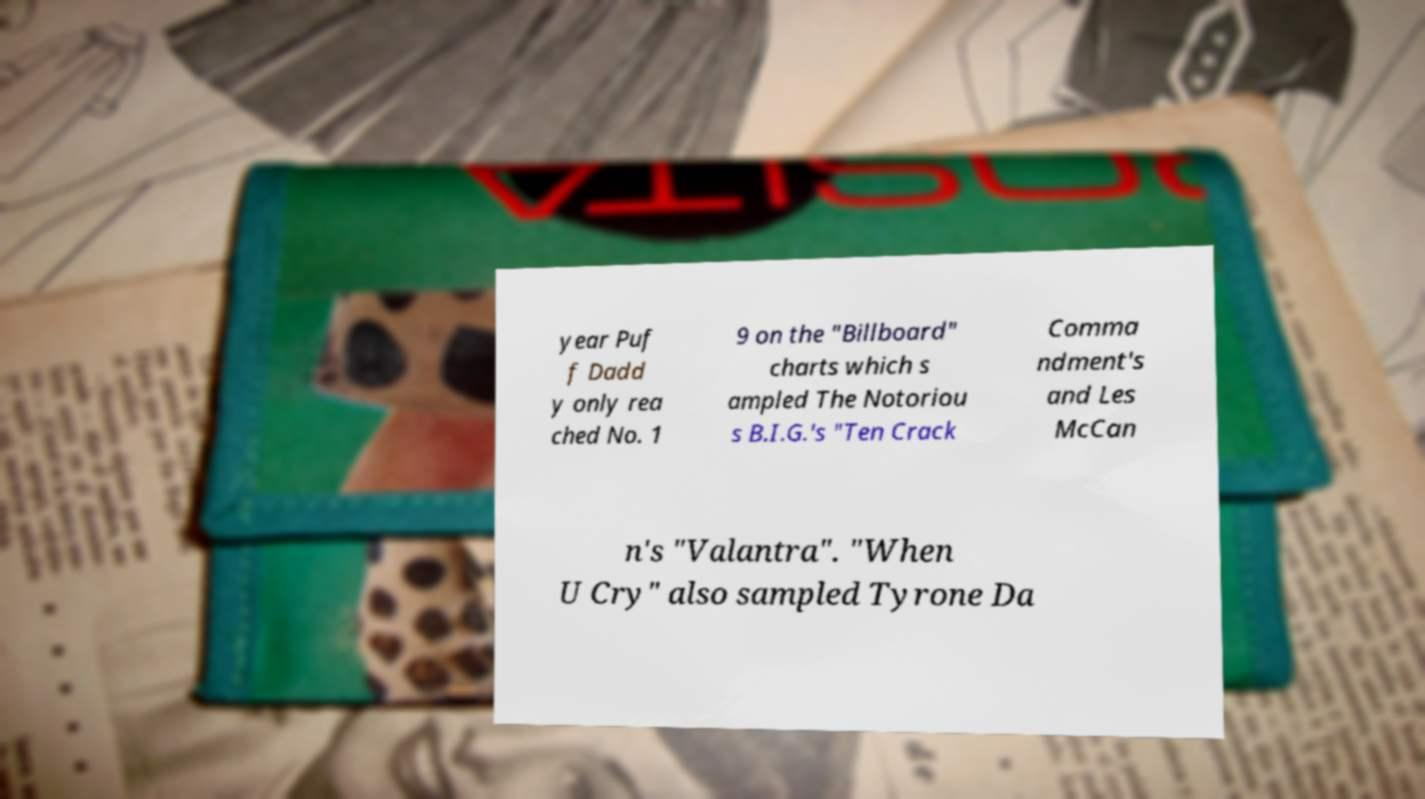There's text embedded in this image that I need extracted. Can you transcribe it verbatim? year Puf f Dadd y only rea ched No. 1 9 on the "Billboard" charts which s ampled The Notoriou s B.I.G.'s "Ten Crack Comma ndment's and Les McCan n's "Valantra". "When U Cry" also sampled Tyrone Da 